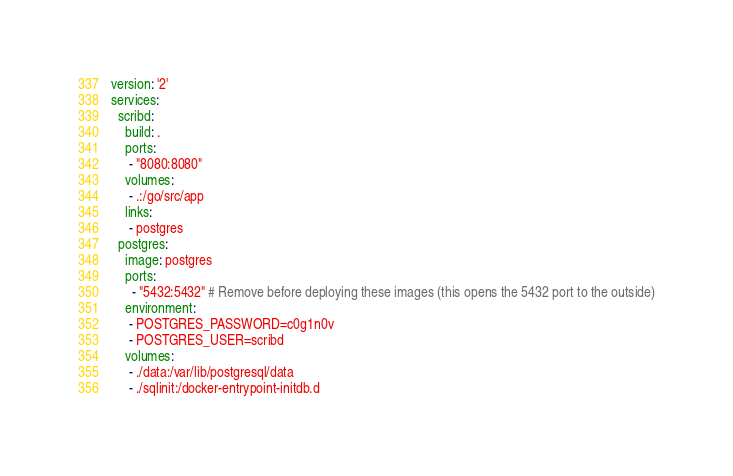Convert code to text. <code><loc_0><loc_0><loc_500><loc_500><_YAML_> version: '2'
 services:
   scribd:
     build: .
     ports:
      - "8080:8080"
     volumes:
      - .:/go/src/app
     links:
      - postgres
   postgres:
     image: postgres
     ports:
       - "5432:5432" # Remove before deploying these images (this opens the 5432 port to the outside)
     environment:
      - POSTGRES_PASSWORD=c0g1n0v
      - POSTGRES_USER=scribd
     volumes:
      - ./data:/var/lib/postgresql/data
      - ./sqlinit:/docker-entrypoint-initdb.d
</code> 